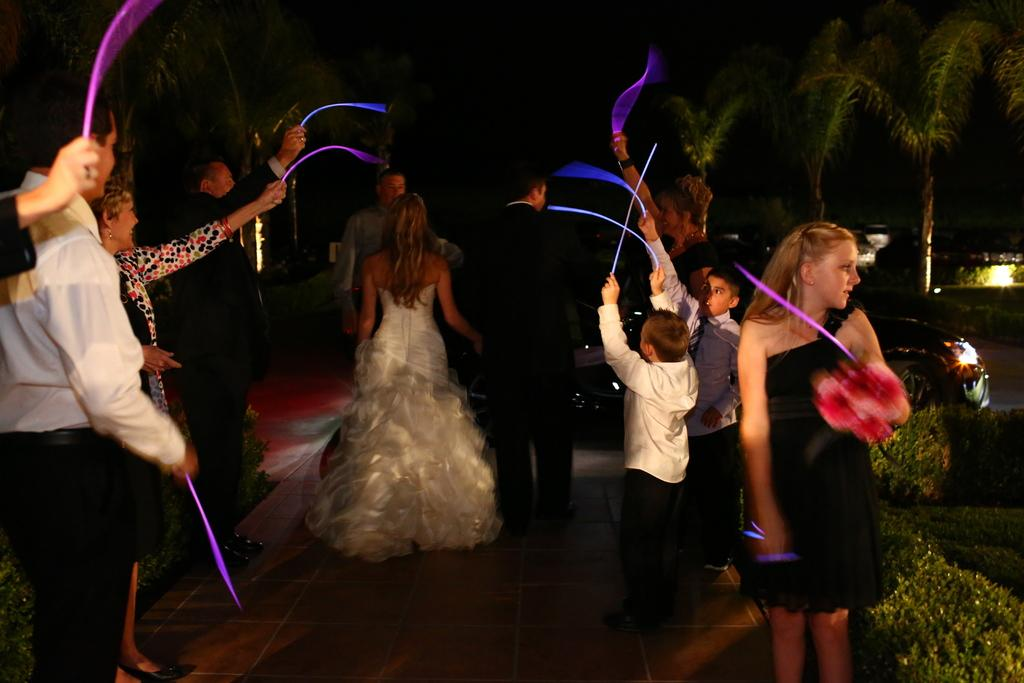What is happening with the group of people in the image? The group of people is standing on the ground in the image. What else can be seen in the image besides the people? Vehicles, plants, trees, and some objects are present in the image. Can you describe the background of the image? The background of the image is dark. Where is the honey dripping from in the image? There is no honey present in the image. How many crows are sitting on the trees in the image? There are no crows visible in the image; only trees are mentioned. 